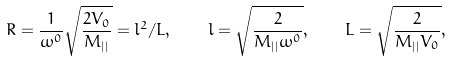<formula> <loc_0><loc_0><loc_500><loc_500>R = \frac { 1 } { \omega ^ { 0 } } \sqrt { \frac { 2 V _ { 0 } } { M _ { | | } } } = l ^ { 2 } / L , \quad l = \sqrt { \frac { 2 } { M _ { | | } \omega ^ { 0 } } } , \quad L = \sqrt { \frac { 2 } { M _ { | | } V _ { 0 } } } ,</formula> 